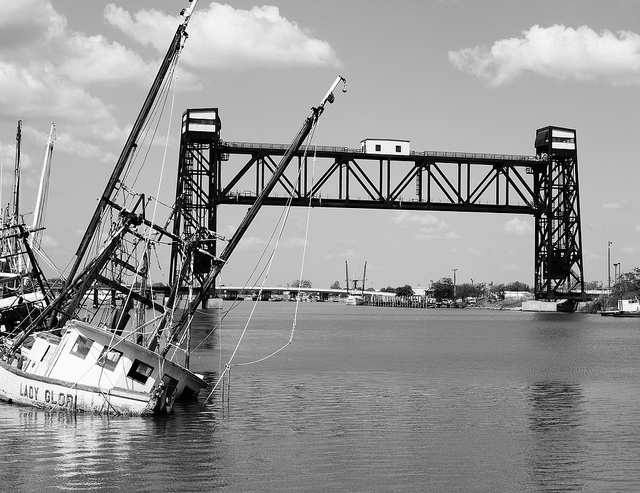Describe the objects in this image and their specific colors. I can see boat in lightgray, black, darkgray, and gray tones and boat in lightgray, darkgray, gray, and black tones in this image. 